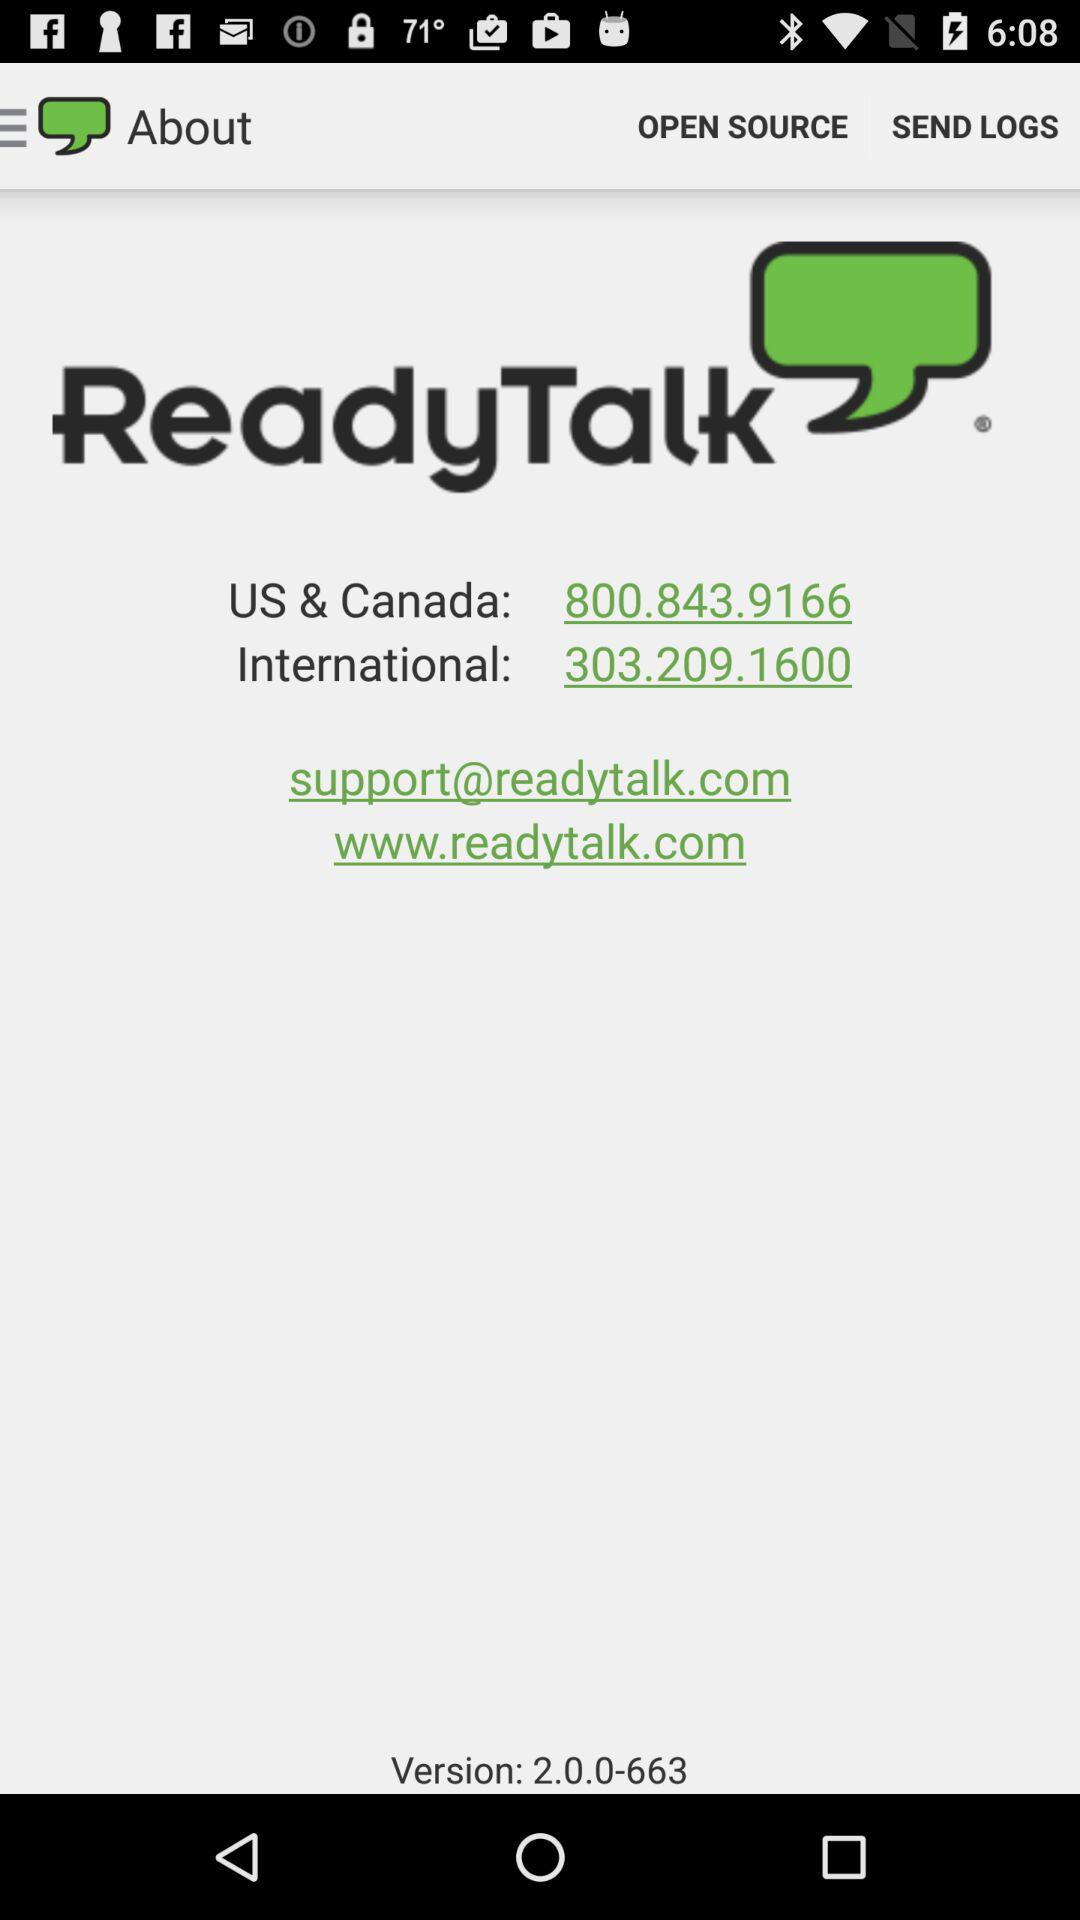What is the given phone number? The given phone numbers are 800.843.9166 and 303.209.1600. 